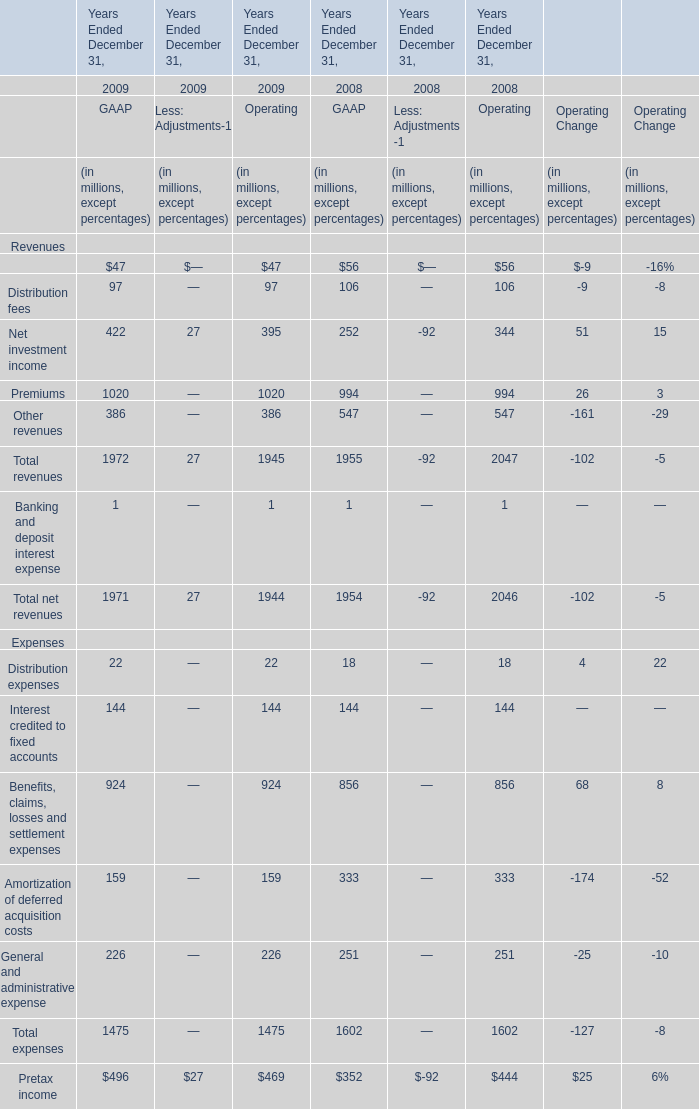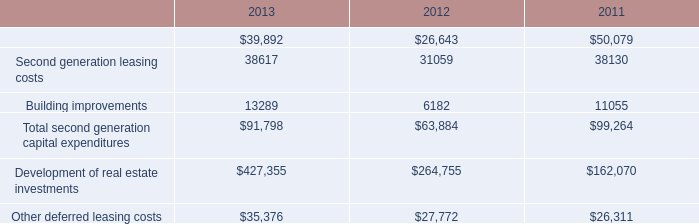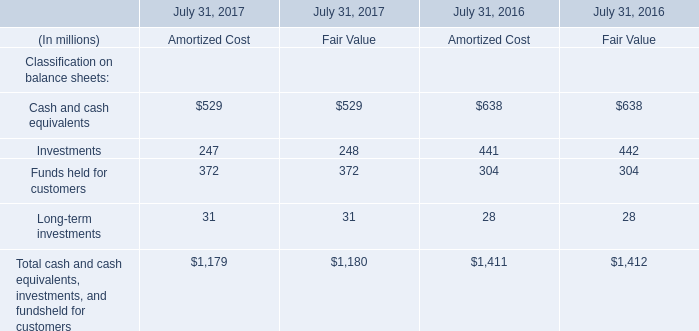What's the average of Management and financial advice fees and Distribution fees and Net investment income of GAAP in 2009? (in millions) 
Computations: (((47 + 97) + 422) / 3)
Answer: 188.66667. 